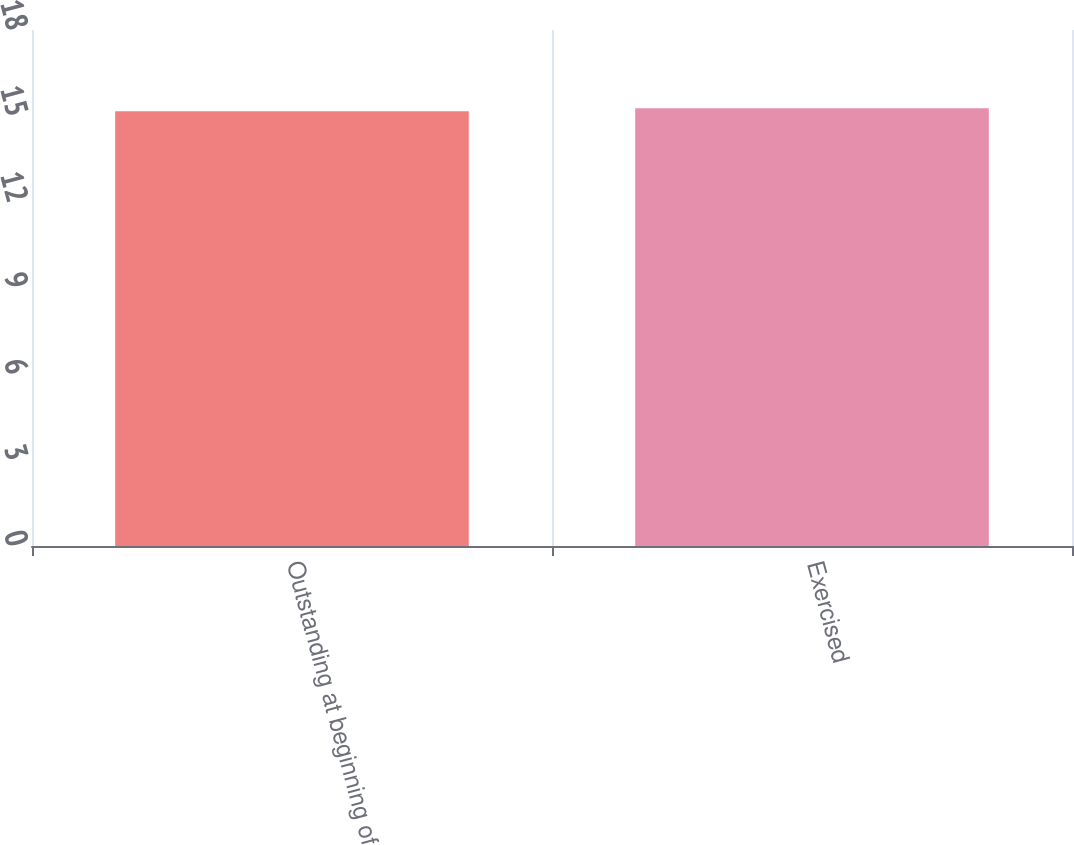Convert chart. <chart><loc_0><loc_0><loc_500><loc_500><bar_chart><fcel>Outstanding at beginning of<fcel>Exercised<nl><fcel>15.17<fcel>15.27<nl></chart> 